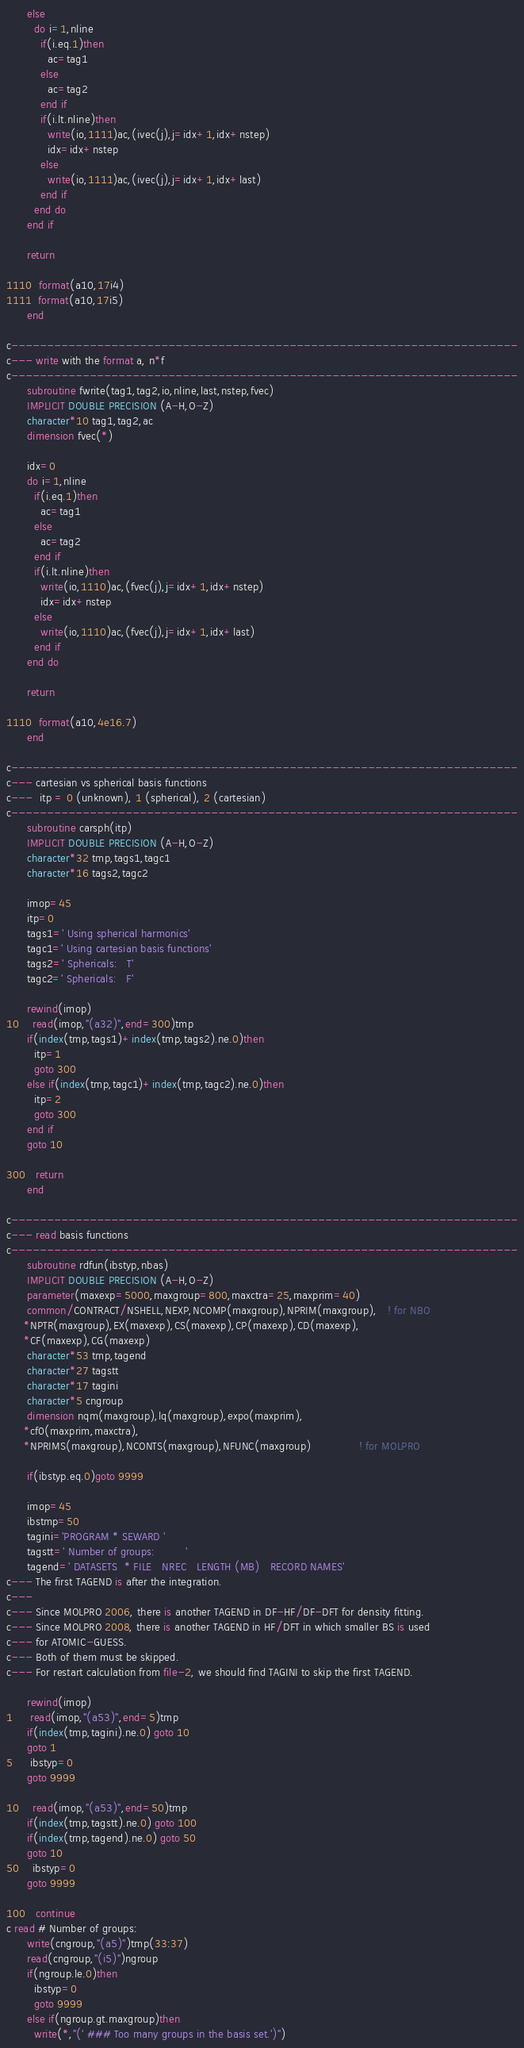<code> <loc_0><loc_0><loc_500><loc_500><_FORTRAN_>      else
        do i=1,nline
          if(i.eq.1)then
            ac=tag1
          else
            ac=tag2
          end if
          if(i.lt.nline)then
            write(io,1111)ac,(ivec(j),j=idx+1,idx+nstep)
            idx=idx+nstep
          else
            write(io,1111)ac,(ivec(j),j=idx+1,idx+last)
          end if
        end do
      end if

      return

1110  format(a10,17i4)
1111  format(a10,17i5)
      end

c-----------------------------------------------------------------------
c--- write with the format a, n*f
c-----------------------------------------------------------------------
      subroutine fwrite(tag1,tag2,io,nline,last,nstep,fvec)
      IMPLICIT DOUBLE PRECISION (A-H,O-Z)
      character*10 tag1,tag2,ac
      dimension fvec(*)

      idx=0
      do i=1,nline
        if(i.eq.1)then
          ac=tag1
        else
          ac=tag2
        end if
        if(i.lt.nline)then
          write(io,1110)ac,(fvec(j),j=idx+1,idx+nstep)
          idx=idx+nstep
        else
          write(io,1110)ac,(fvec(j),j=idx+1,idx+last)
        end if
      end do

      return

1110  format(a10,4e16.7)
      end

c-----------------------------------------------------------------------
c--- cartesian vs spherical basis functions
c---  itp = 0 (unknown), 1 (spherical), 2 (cartesian)
c-----------------------------------------------------------------------
      subroutine carsph(itp)
      IMPLICIT DOUBLE PRECISION (A-H,O-Z)
      character*32 tmp,tags1,tagc1
      character*16 tags2,tagc2

      imop=45
      itp=0
      tags1=' Using spherical harmonics'
      tagc1=' Using cartesian basis functions'
      tags2=' Sphericals:   T'
      tagc2=' Sphericals:   F'

      rewind(imop)
10    read(imop,"(a32)",end=300)tmp
      if(index(tmp,tags1)+index(tmp,tags2).ne.0)then
        itp=1
        goto 300
      else if(index(tmp,tagc1)+index(tmp,tagc2).ne.0)then
        itp=2
        goto 300
      end if
      goto 10

300   return
      end

c-----------------------------------------------------------------------
c--- read basis functions
c-----------------------------------------------------------------------
      subroutine rdfun(ibstyp,nbas)
      IMPLICIT DOUBLE PRECISION (A-H,O-Z)
      parameter(maxexp=5000,maxgroup=800,maxctra=25,maxprim=40)
      common/CONTRACT/NSHELL,NEXP,NCOMP(maxgroup),NPRIM(maxgroup),   ! for NBO
     *NPTR(maxgroup),EX(maxexp),CS(maxexp),CP(maxexp),CD(maxexp),
     *CF(maxexp),CG(maxexp)
      character*53 tmp,tagend
      character*27 tagstt
      character*17 tagini
      character*5 cngroup
      dimension nqm(maxgroup),lq(maxgroup),expo(maxprim),
     *cf0(maxprim,maxctra),
     *NPRIMS(maxgroup),NCONTS(maxgroup),NFUNC(maxgroup)              ! for MOLPRO

      if(ibstyp.eq.0)goto 9999

      imop=45
      ibstmp=50
      tagini='PROGRAM * SEWARD '
      tagstt=' Number of groups:         '
      tagend=' DATASETS  * FILE   NREC   LENGTH (MB)   RECORD NAMES'
c--- The first TAGEND is after the integration.
c---
c--- Since MOLPRO 2006, there is another TAGEND in DF-HF/DF-DFT for density fitting.
c--- Since MOLPRO 2008, there is another TAGEND in HF/DFT in which smaller BS is used
c--- for ATOMIC-GUESS.
c--- Both of them must be skipped.
c--- For restart calculation from file-2, we should find TAGINI to skip the first TAGEND.

      rewind(imop)
1     read(imop,"(a53)",end=5)tmp
      if(index(tmp,tagini).ne.0) goto 10
      goto 1
5     ibstyp=0
      goto 9999

10    read(imop,"(a53)",end=50)tmp
      if(index(tmp,tagstt).ne.0) goto 100
      if(index(tmp,tagend).ne.0) goto 50
      goto 10
50    ibstyp=0
      goto 9999

100   continue
c read # Number of groups:
      write(cngroup,"(a5)")tmp(33:37)
      read(cngroup,"(i5)")ngroup
      if(ngroup.le.0)then
        ibstyp=0
        goto 9999
      else if(ngroup.gt.maxgroup)then
        write(*,"(' ### Too many groups in the basis set.')")</code> 